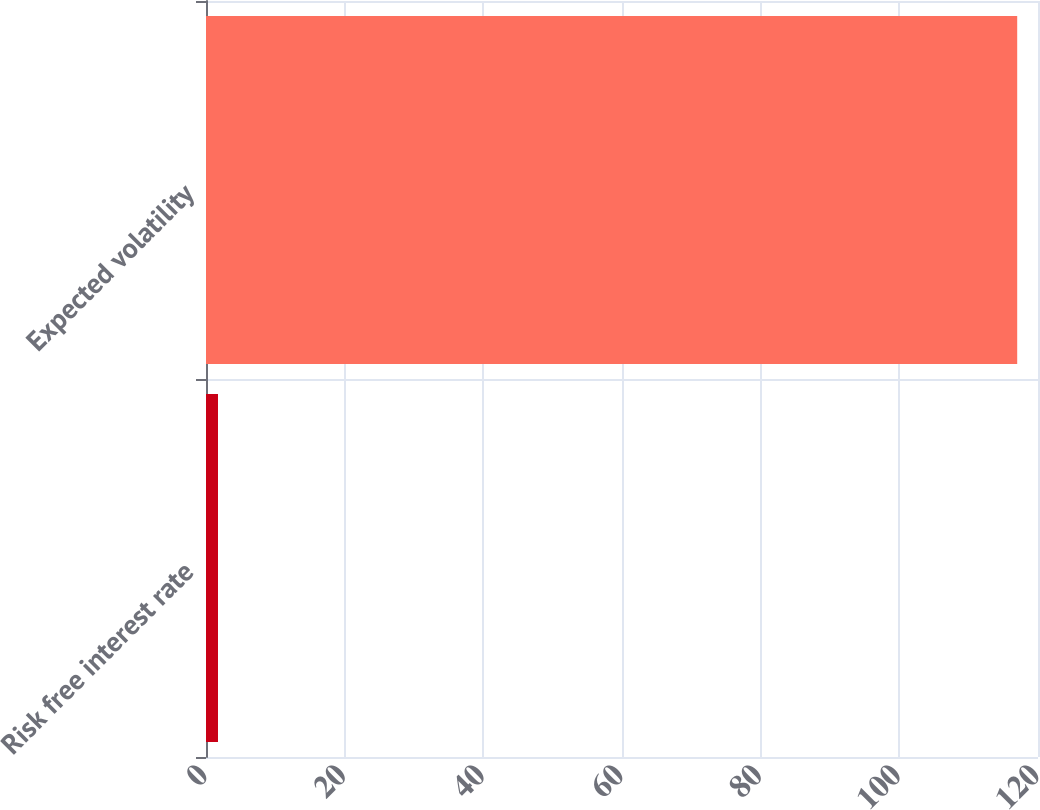Convert chart. <chart><loc_0><loc_0><loc_500><loc_500><bar_chart><fcel>Risk free interest rate<fcel>Expected volatility<nl><fcel>1.73<fcel>117<nl></chart> 